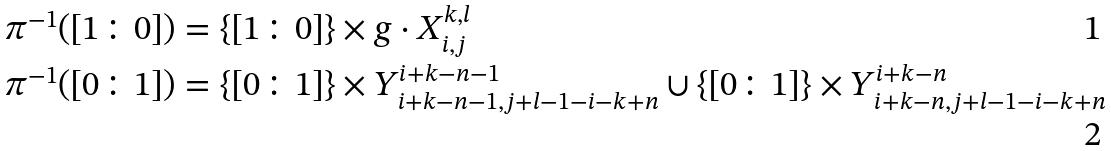<formula> <loc_0><loc_0><loc_500><loc_500>\pi ^ { - 1 } ( [ 1 \colon 0 ] ) & = \{ [ 1 \colon 0 ] \} \times g \cdot X _ { i , j } ^ { k , l } \\ \pi ^ { - 1 } ( [ 0 \colon 1 ] ) & = \{ [ 0 \colon 1 ] \} \times Y _ { i + k - n - 1 , j + l - 1 - i - k + n } ^ { i + k - n - 1 } \cup \{ [ 0 \colon 1 ] \} \times Y _ { i + k - n , j + l - 1 - i - k + n } ^ { i + k - n }</formula> 